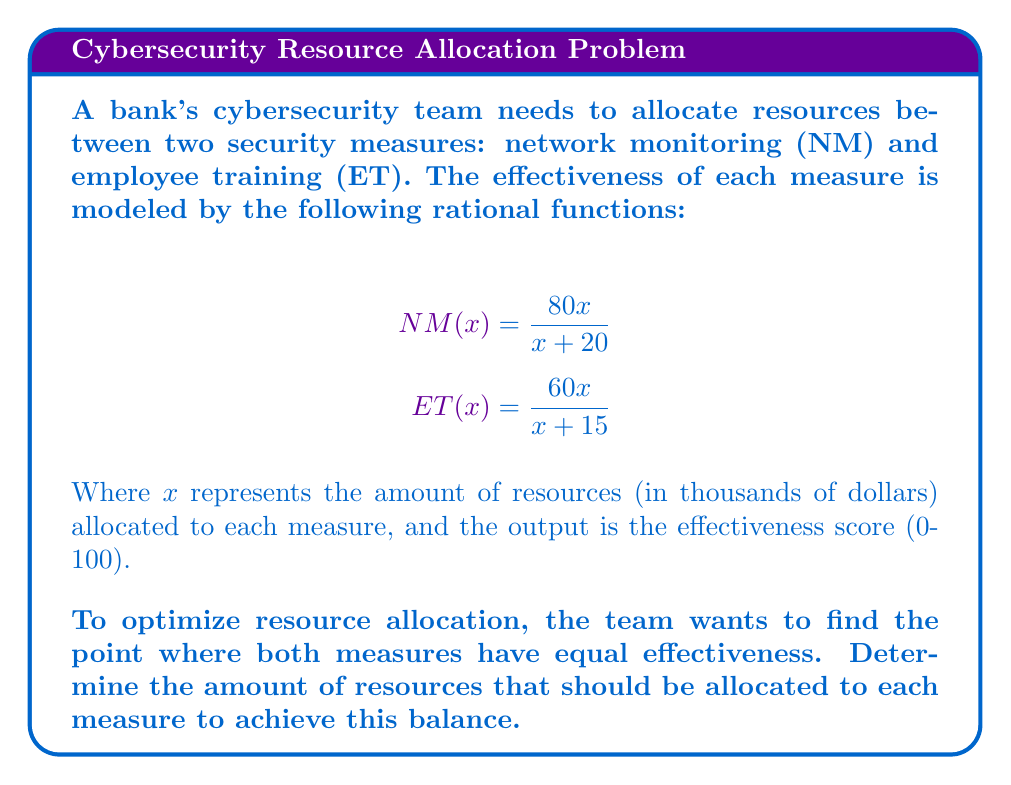Show me your answer to this math problem. To solve this problem, we need to set the two equations equal to each other and solve for x:

1) Set the equations equal:
   $$\frac{80x}{x + 20} = \frac{60x}{x + 15}$$

2) Cross-multiply to eliminate denominators:
   $$80x(x + 15) = 60x(x + 20)$$

3) Expand the brackets:
   $$80x^2 + 1200x = 60x^2 + 1200x$$

4) Subtract 60x^2 and 1200x from both sides:
   $$20x^2 = 0$$

5) Divide both sides by 20:
   $$x^2 = 0$$

6) Take the square root of both sides:
   $$x = 0$$

7) However, x = 0 doesn't make sense in the context of resource allocation. This means there's no point where the effectiveness of both measures is exactly equal.

8) To find a practical solution, we can evaluate the functions at different x values:

   For x = 30 (thousand dollars):
   $$NM(30) = \frac{80(30)}{30 + 20} = 60$$
   $$ET(30) = \frac{60(30)}{30 + 15} = 40$$

   For x = 60 (thousand dollars):
   $$NM(60) = \frac{80(60)}{60 + 20} = 67.5$$
   $$ET(60) = \frac{60(60)}{60 + 15} = 48$$

9) We can see that NM is always more effective than ET for positive x values. The closest balance is achieved by allocating equal resources to both measures.
Answer: Allocate equal resources to both measures (e.g., $60,000 each). 